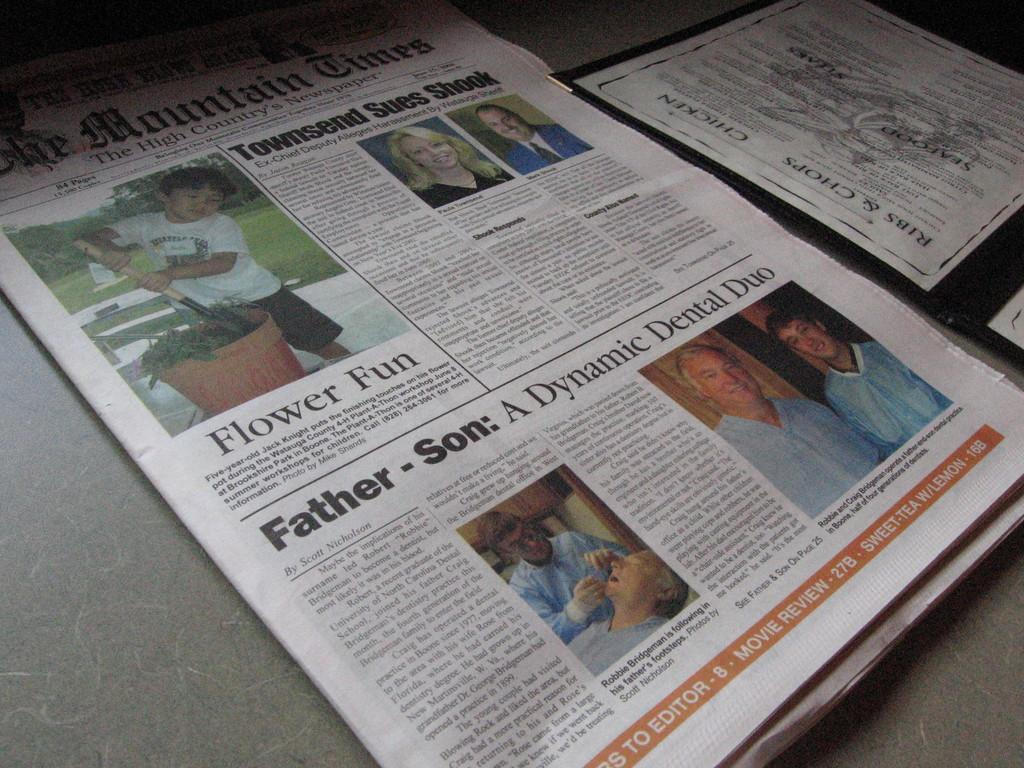<image>
Write a terse but informative summary of the picture. A newspaper from The Mountain Times laying on a table next to a menu. 